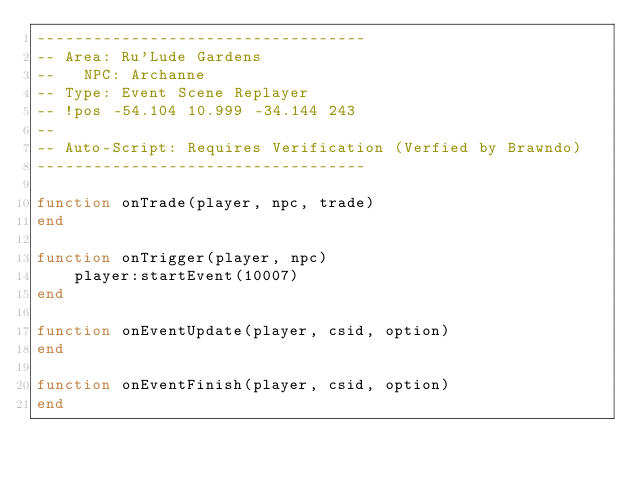Convert code to text. <code><loc_0><loc_0><loc_500><loc_500><_Lua_>-----------------------------------
-- Area: Ru'Lude Gardens
--   NPC: Archanne
-- Type: Event Scene Replayer
-- !pos -54.104 10.999 -34.144 243
--
-- Auto-Script: Requires Verification (Verfied by Brawndo)
-----------------------------------

function onTrade(player, npc, trade)
end

function onTrigger(player, npc)
    player:startEvent(10007)
end

function onEventUpdate(player, csid, option)
end

function onEventFinish(player, csid, option)
end
</code> 